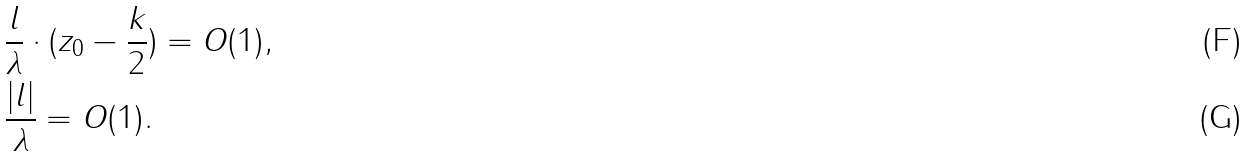<formula> <loc_0><loc_0><loc_500><loc_500>& \frac { l } { \lambda } \cdot ( z _ { 0 } - \frac { k } { 2 } ) = O ( 1 ) , \\ & \frac { | l | } { \lambda } = O ( 1 ) .</formula> 